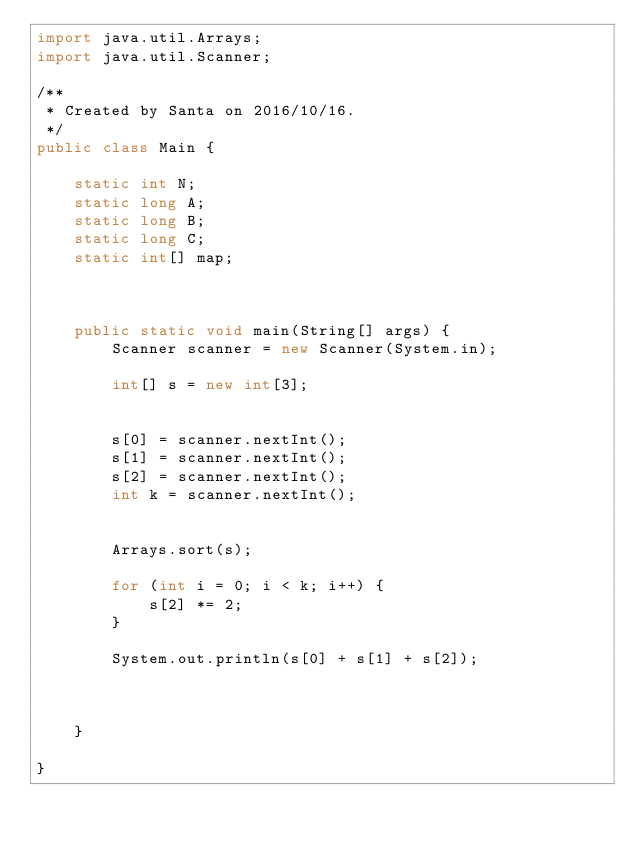<code> <loc_0><loc_0><loc_500><loc_500><_Java_>import java.util.Arrays;
import java.util.Scanner;

/**
 * Created by Santa on 2016/10/16.
 */
public class Main {

    static int N;
    static long A;
    static long B;
    static long C;
    static int[] map;



    public static void main(String[] args) {
        Scanner scanner = new Scanner(System.in);

        int[] s = new int[3];


        s[0] = scanner.nextInt();
        s[1] = scanner.nextInt();
        s[2] = scanner.nextInt();
        int k = scanner.nextInt();


        Arrays.sort(s);

        for (int i = 0; i < k; i++) {
            s[2] *= 2;
        }

        System.out.println(s[0] + s[1] + s[2]);



    }

}

</code> 